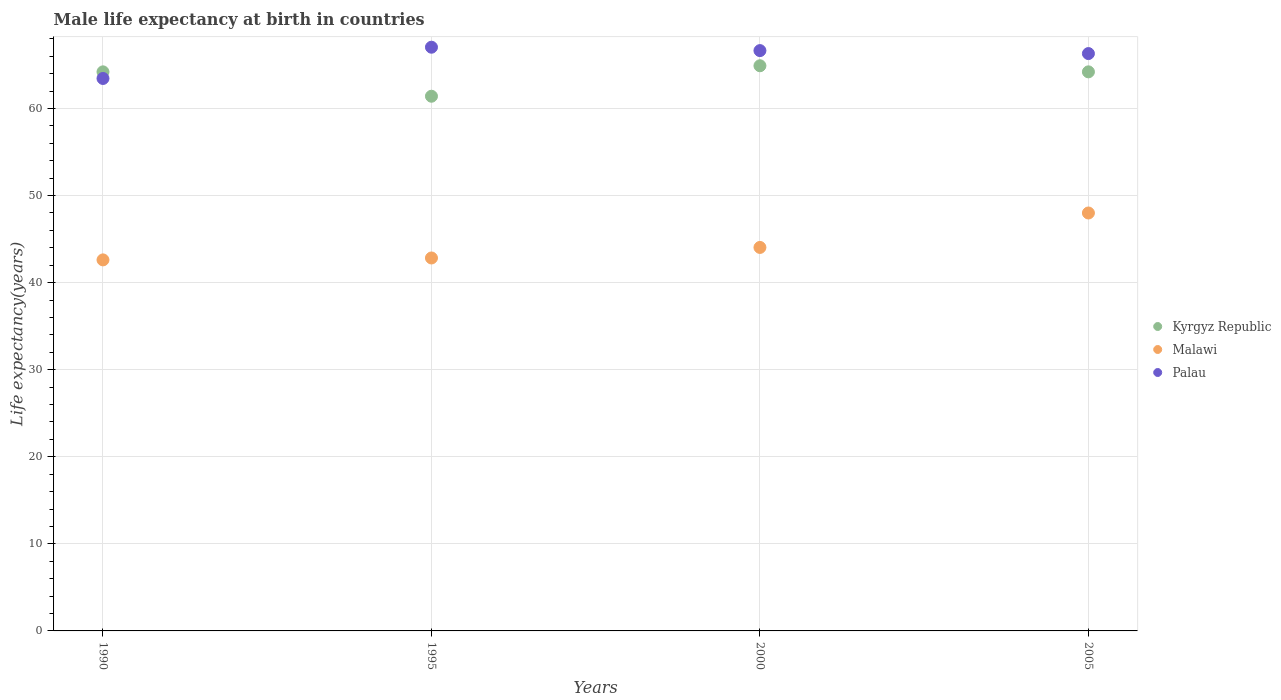What is the male life expectancy at birth in Kyrgyz Republic in 2005?
Provide a succinct answer. 64.2. Across all years, what is the maximum male life expectancy at birth in Malawi?
Offer a terse response. 47.99. Across all years, what is the minimum male life expectancy at birth in Kyrgyz Republic?
Ensure brevity in your answer.  61.4. In which year was the male life expectancy at birth in Malawi minimum?
Give a very brief answer. 1990. What is the total male life expectancy at birth in Palau in the graph?
Provide a succinct answer. 263.41. What is the difference between the male life expectancy at birth in Malawi in 1990 and that in 2000?
Your response must be concise. -1.43. What is the difference between the male life expectancy at birth in Palau in 2000 and the male life expectancy at birth in Kyrgyz Republic in 2005?
Your answer should be very brief. 2.44. What is the average male life expectancy at birth in Palau per year?
Give a very brief answer. 65.85. In the year 2000, what is the difference between the male life expectancy at birth in Palau and male life expectancy at birth in Kyrgyz Republic?
Ensure brevity in your answer.  1.74. What is the ratio of the male life expectancy at birth in Palau in 1990 to that in 2000?
Offer a terse response. 0.95. What is the difference between the highest and the second highest male life expectancy at birth in Malawi?
Give a very brief answer. 3.96. What is the difference between the highest and the lowest male life expectancy at birth in Kyrgyz Republic?
Ensure brevity in your answer.  3.5. In how many years, is the male life expectancy at birth in Kyrgyz Republic greater than the average male life expectancy at birth in Kyrgyz Republic taken over all years?
Make the answer very short. 3. Is it the case that in every year, the sum of the male life expectancy at birth in Palau and male life expectancy at birth in Malawi  is greater than the male life expectancy at birth in Kyrgyz Republic?
Give a very brief answer. Yes. Does the male life expectancy at birth in Palau monotonically increase over the years?
Your answer should be very brief. No. How many dotlines are there?
Provide a succinct answer. 3. Are the values on the major ticks of Y-axis written in scientific E-notation?
Provide a succinct answer. No. Does the graph contain grids?
Make the answer very short. Yes. Where does the legend appear in the graph?
Ensure brevity in your answer.  Center right. What is the title of the graph?
Your answer should be compact. Male life expectancy at birth in countries. What is the label or title of the Y-axis?
Provide a succinct answer. Life expectancy(years). What is the Life expectancy(years) of Kyrgyz Republic in 1990?
Ensure brevity in your answer.  64.2. What is the Life expectancy(years) of Malawi in 1990?
Ensure brevity in your answer.  42.61. What is the Life expectancy(years) in Palau in 1990?
Offer a very short reply. 63.44. What is the Life expectancy(years) of Kyrgyz Republic in 1995?
Your response must be concise. 61.4. What is the Life expectancy(years) of Malawi in 1995?
Offer a terse response. 42.83. What is the Life expectancy(years) in Palau in 1995?
Keep it short and to the point. 67.03. What is the Life expectancy(years) of Kyrgyz Republic in 2000?
Give a very brief answer. 64.9. What is the Life expectancy(years) in Malawi in 2000?
Ensure brevity in your answer.  44.04. What is the Life expectancy(years) of Palau in 2000?
Your answer should be very brief. 66.64. What is the Life expectancy(years) in Kyrgyz Republic in 2005?
Your response must be concise. 64.2. What is the Life expectancy(years) in Malawi in 2005?
Offer a very short reply. 47.99. What is the Life expectancy(years) of Palau in 2005?
Give a very brief answer. 66.3. Across all years, what is the maximum Life expectancy(years) in Kyrgyz Republic?
Provide a succinct answer. 64.9. Across all years, what is the maximum Life expectancy(years) of Malawi?
Your answer should be compact. 47.99. Across all years, what is the maximum Life expectancy(years) in Palau?
Offer a terse response. 67.03. Across all years, what is the minimum Life expectancy(years) of Kyrgyz Republic?
Your response must be concise. 61.4. Across all years, what is the minimum Life expectancy(years) of Malawi?
Provide a succinct answer. 42.61. Across all years, what is the minimum Life expectancy(years) in Palau?
Offer a terse response. 63.44. What is the total Life expectancy(years) of Kyrgyz Republic in the graph?
Provide a succinct answer. 254.7. What is the total Life expectancy(years) of Malawi in the graph?
Offer a very short reply. 177.46. What is the total Life expectancy(years) in Palau in the graph?
Your answer should be compact. 263.41. What is the difference between the Life expectancy(years) of Kyrgyz Republic in 1990 and that in 1995?
Your answer should be very brief. 2.8. What is the difference between the Life expectancy(years) in Malawi in 1990 and that in 1995?
Provide a succinct answer. -0.22. What is the difference between the Life expectancy(years) of Palau in 1990 and that in 1995?
Give a very brief answer. -3.59. What is the difference between the Life expectancy(years) of Malawi in 1990 and that in 2000?
Provide a succinct answer. -1.43. What is the difference between the Life expectancy(years) of Kyrgyz Republic in 1990 and that in 2005?
Your answer should be compact. 0. What is the difference between the Life expectancy(years) of Malawi in 1990 and that in 2005?
Provide a short and direct response. -5.39. What is the difference between the Life expectancy(years) of Palau in 1990 and that in 2005?
Offer a terse response. -2.86. What is the difference between the Life expectancy(years) in Kyrgyz Republic in 1995 and that in 2000?
Make the answer very short. -3.5. What is the difference between the Life expectancy(years) of Malawi in 1995 and that in 2000?
Your answer should be compact. -1.21. What is the difference between the Life expectancy(years) of Palau in 1995 and that in 2000?
Provide a succinct answer. 0.39. What is the difference between the Life expectancy(years) in Malawi in 1995 and that in 2005?
Offer a terse response. -5.17. What is the difference between the Life expectancy(years) of Palau in 1995 and that in 2005?
Your answer should be compact. 0.73. What is the difference between the Life expectancy(years) in Malawi in 2000 and that in 2005?
Give a very brief answer. -3.96. What is the difference between the Life expectancy(years) in Palau in 2000 and that in 2005?
Make the answer very short. 0.34. What is the difference between the Life expectancy(years) in Kyrgyz Republic in 1990 and the Life expectancy(years) in Malawi in 1995?
Keep it short and to the point. 21.37. What is the difference between the Life expectancy(years) of Kyrgyz Republic in 1990 and the Life expectancy(years) of Palau in 1995?
Your answer should be very brief. -2.83. What is the difference between the Life expectancy(years) in Malawi in 1990 and the Life expectancy(years) in Palau in 1995?
Keep it short and to the point. -24.42. What is the difference between the Life expectancy(years) of Kyrgyz Republic in 1990 and the Life expectancy(years) of Malawi in 2000?
Offer a very short reply. 20.16. What is the difference between the Life expectancy(years) in Kyrgyz Republic in 1990 and the Life expectancy(years) in Palau in 2000?
Provide a succinct answer. -2.44. What is the difference between the Life expectancy(years) in Malawi in 1990 and the Life expectancy(years) in Palau in 2000?
Your answer should be very brief. -24.03. What is the difference between the Life expectancy(years) in Kyrgyz Republic in 1990 and the Life expectancy(years) in Malawi in 2005?
Provide a succinct answer. 16.21. What is the difference between the Life expectancy(years) of Kyrgyz Republic in 1990 and the Life expectancy(years) of Palau in 2005?
Make the answer very short. -2.1. What is the difference between the Life expectancy(years) in Malawi in 1990 and the Life expectancy(years) in Palau in 2005?
Offer a very short reply. -23.69. What is the difference between the Life expectancy(years) of Kyrgyz Republic in 1995 and the Life expectancy(years) of Malawi in 2000?
Ensure brevity in your answer.  17.36. What is the difference between the Life expectancy(years) in Kyrgyz Republic in 1995 and the Life expectancy(years) in Palau in 2000?
Offer a terse response. -5.24. What is the difference between the Life expectancy(years) of Malawi in 1995 and the Life expectancy(years) of Palau in 2000?
Provide a succinct answer. -23.81. What is the difference between the Life expectancy(years) of Kyrgyz Republic in 1995 and the Life expectancy(years) of Malawi in 2005?
Give a very brief answer. 13.41. What is the difference between the Life expectancy(years) of Malawi in 1995 and the Life expectancy(years) of Palau in 2005?
Keep it short and to the point. -23.47. What is the difference between the Life expectancy(years) in Kyrgyz Republic in 2000 and the Life expectancy(years) in Malawi in 2005?
Provide a succinct answer. 16.91. What is the difference between the Life expectancy(years) in Malawi in 2000 and the Life expectancy(years) in Palau in 2005?
Keep it short and to the point. -22.26. What is the average Life expectancy(years) in Kyrgyz Republic per year?
Provide a short and direct response. 63.67. What is the average Life expectancy(years) of Malawi per year?
Provide a short and direct response. 44.37. What is the average Life expectancy(years) in Palau per year?
Give a very brief answer. 65.85. In the year 1990, what is the difference between the Life expectancy(years) of Kyrgyz Republic and Life expectancy(years) of Malawi?
Provide a short and direct response. 21.59. In the year 1990, what is the difference between the Life expectancy(years) of Kyrgyz Republic and Life expectancy(years) of Palau?
Give a very brief answer. 0.76. In the year 1990, what is the difference between the Life expectancy(years) of Malawi and Life expectancy(years) of Palau?
Your response must be concise. -20.83. In the year 1995, what is the difference between the Life expectancy(years) of Kyrgyz Republic and Life expectancy(years) of Malawi?
Your response must be concise. 18.57. In the year 1995, what is the difference between the Life expectancy(years) in Kyrgyz Republic and Life expectancy(years) in Palau?
Offer a terse response. -5.63. In the year 1995, what is the difference between the Life expectancy(years) of Malawi and Life expectancy(years) of Palau?
Ensure brevity in your answer.  -24.2. In the year 2000, what is the difference between the Life expectancy(years) of Kyrgyz Republic and Life expectancy(years) of Malawi?
Your answer should be compact. 20.86. In the year 2000, what is the difference between the Life expectancy(years) in Kyrgyz Republic and Life expectancy(years) in Palau?
Offer a very short reply. -1.74. In the year 2000, what is the difference between the Life expectancy(years) of Malawi and Life expectancy(years) of Palau?
Your response must be concise. -22.6. In the year 2005, what is the difference between the Life expectancy(years) of Kyrgyz Republic and Life expectancy(years) of Malawi?
Provide a succinct answer. 16.21. In the year 2005, what is the difference between the Life expectancy(years) in Kyrgyz Republic and Life expectancy(years) in Palau?
Provide a short and direct response. -2.1. In the year 2005, what is the difference between the Life expectancy(years) in Malawi and Life expectancy(years) in Palau?
Offer a terse response. -18.31. What is the ratio of the Life expectancy(years) in Kyrgyz Republic in 1990 to that in 1995?
Your response must be concise. 1.05. What is the ratio of the Life expectancy(years) in Malawi in 1990 to that in 1995?
Your response must be concise. 0.99. What is the ratio of the Life expectancy(years) of Palau in 1990 to that in 1995?
Your answer should be compact. 0.95. What is the ratio of the Life expectancy(years) of Malawi in 1990 to that in 2000?
Provide a succinct answer. 0.97. What is the ratio of the Life expectancy(years) in Kyrgyz Republic in 1990 to that in 2005?
Provide a short and direct response. 1. What is the ratio of the Life expectancy(years) in Malawi in 1990 to that in 2005?
Ensure brevity in your answer.  0.89. What is the ratio of the Life expectancy(years) of Palau in 1990 to that in 2005?
Give a very brief answer. 0.96. What is the ratio of the Life expectancy(years) in Kyrgyz Republic in 1995 to that in 2000?
Offer a very short reply. 0.95. What is the ratio of the Life expectancy(years) in Malawi in 1995 to that in 2000?
Make the answer very short. 0.97. What is the ratio of the Life expectancy(years) in Palau in 1995 to that in 2000?
Your answer should be compact. 1.01. What is the ratio of the Life expectancy(years) of Kyrgyz Republic in 1995 to that in 2005?
Give a very brief answer. 0.96. What is the ratio of the Life expectancy(years) of Malawi in 1995 to that in 2005?
Offer a terse response. 0.89. What is the ratio of the Life expectancy(years) in Palau in 1995 to that in 2005?
Offer a very short reply. 1.01. What is the ratio of the Life expectancy(years) in Kyrgyz Republic in 2000 to that in 2005?
Offer a very short reply. 1.01. What is the ratio of the Life expectancy(years) in Malawi in 2000 to that in 2005?
Your response must be concise. 0.92. What is the ratio of the Life expectancy(years) in Palau in 2000 to that in 2005?
Your answer should be very brief. 1.01. What is the difference between the highest and the second highest Life expectancy(years) in Kyrgyz Republic?
Keep it short and to the point. 0.7. What is the difference between the highest and the second highest Life expectancy(years) of Malawi?
Provide a succinct answer. 3.96. What is the difference between the highest and the second highest Life expectancy(years) of Palau?
Provide a short and direct response. 0.39. What is the difference between the highest and the lowest Life expectancy(years) in Kyrgyz Republic?
Your answer should be compact. 3.5. What is the difference between the highest and the lowest Life expectancy(years) in Malawi?
Ensure brevity in your answer.  5.39. What is the difference between the highest and the lowest Life expectancy(years) of Palau?
Offer a very short reply. 3.59. 